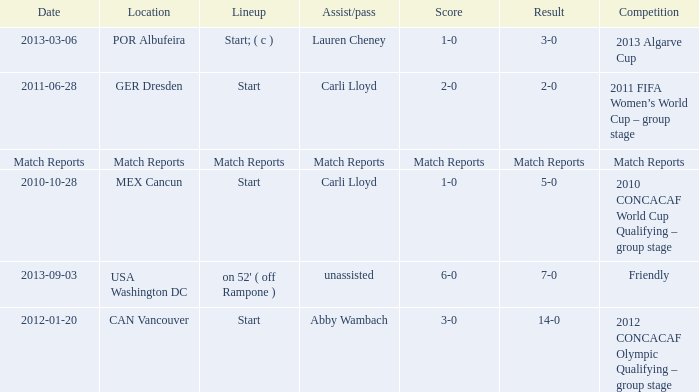Where has a score of match reports? Match Reports. 